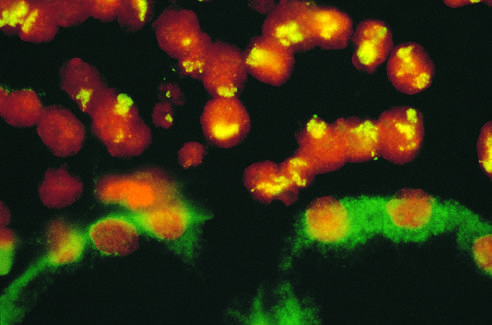do renal tubular epithelial cells in the lower half of the photograph show no nuclear staining and background cytoplasmic staining?
Answer the question using a single word or phrase. Yes 